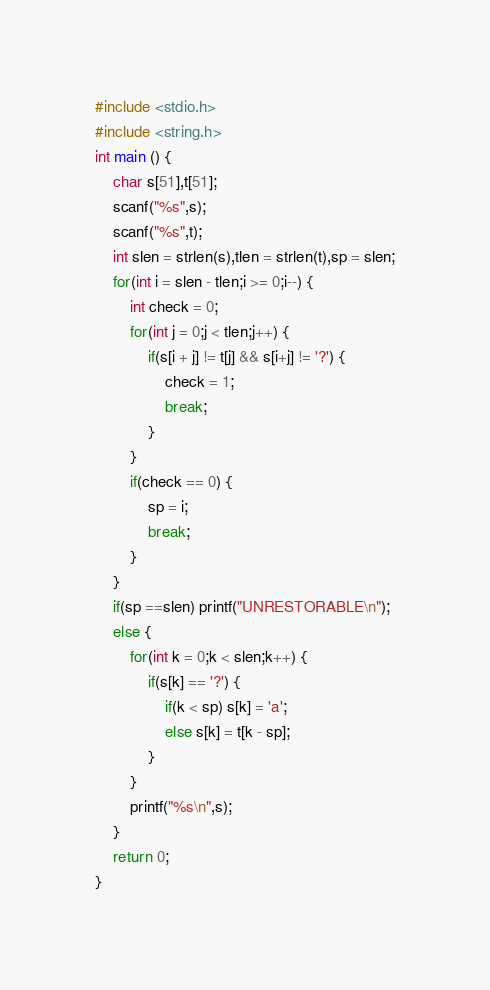<code> <loc_0><loc_0><loc_500><loc_500><_C_>#include <stdio.h>
#include <string.h>
int main () {
	char s[51],t[51];
	scanf("%s",s);
	scanf("%s",t);
	int slen = strlen(s),tlen = strlen(t),sp = slen;
	for(int i = slen - tlen;i >= 0;i--) {
		int check = 0;
		for(int j = 0;j < tlen;j++) {
			if(s[i + j] != t[j] && s[i+j] != '?') {
				check = 1;
				break;
			}
		}
		if(check == 0) {
			sp = i;
			break;
		}
	}
	if(sp ==slen) printf("UNRESTORABLE\n");
	else {
		for(int k = 0;k < slen;k++) {
			if(s[k] == '?') {
				if(k < sp) s[k] = 'a';
				else s[k] = t[k - sp];
			}
		}
		printf("%s\n",s);
	}
	return 0;
}</code> 